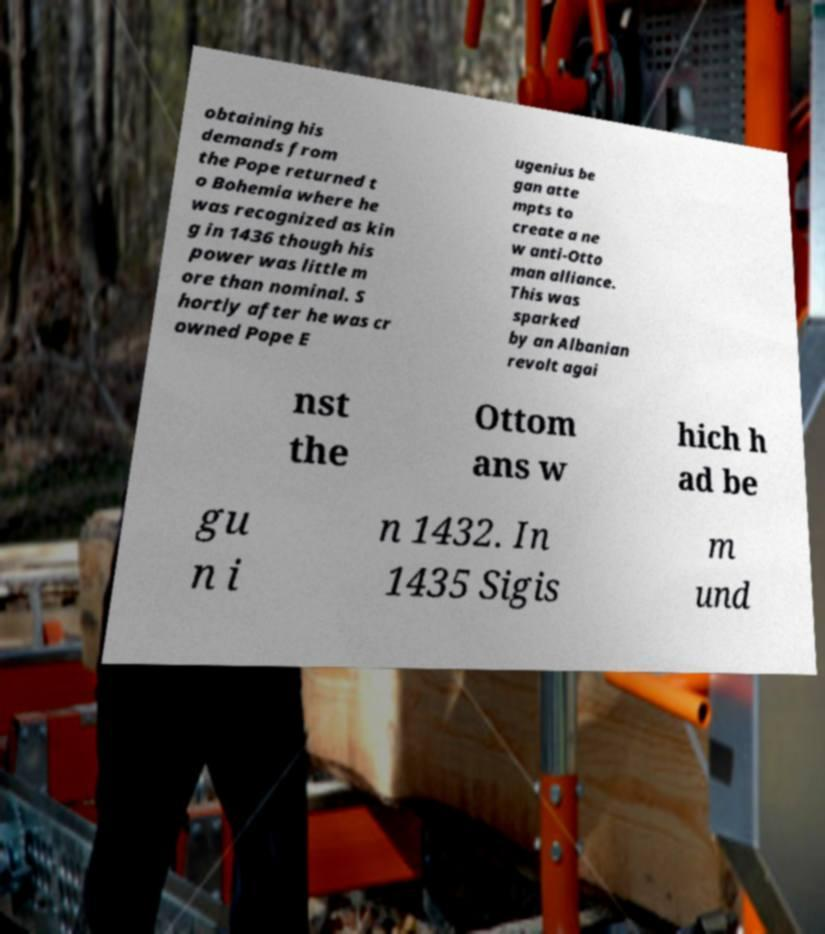Could you assist in decoding the text presented in this image and type it out clearly? obtaining his demands from the Pope returned t o Bohemia where he was recognized as kin g in 1436 though his power was little m ore than nominal. S hortly after he was cr owned Pope E ugenius be gan atte mpts to create a ne w anti-Otto man alliance. This was sparked by an Albanian revolt agai nst the Ottom ans w hich h ad be gu n i n 1432. In 1435 Sigis m und 